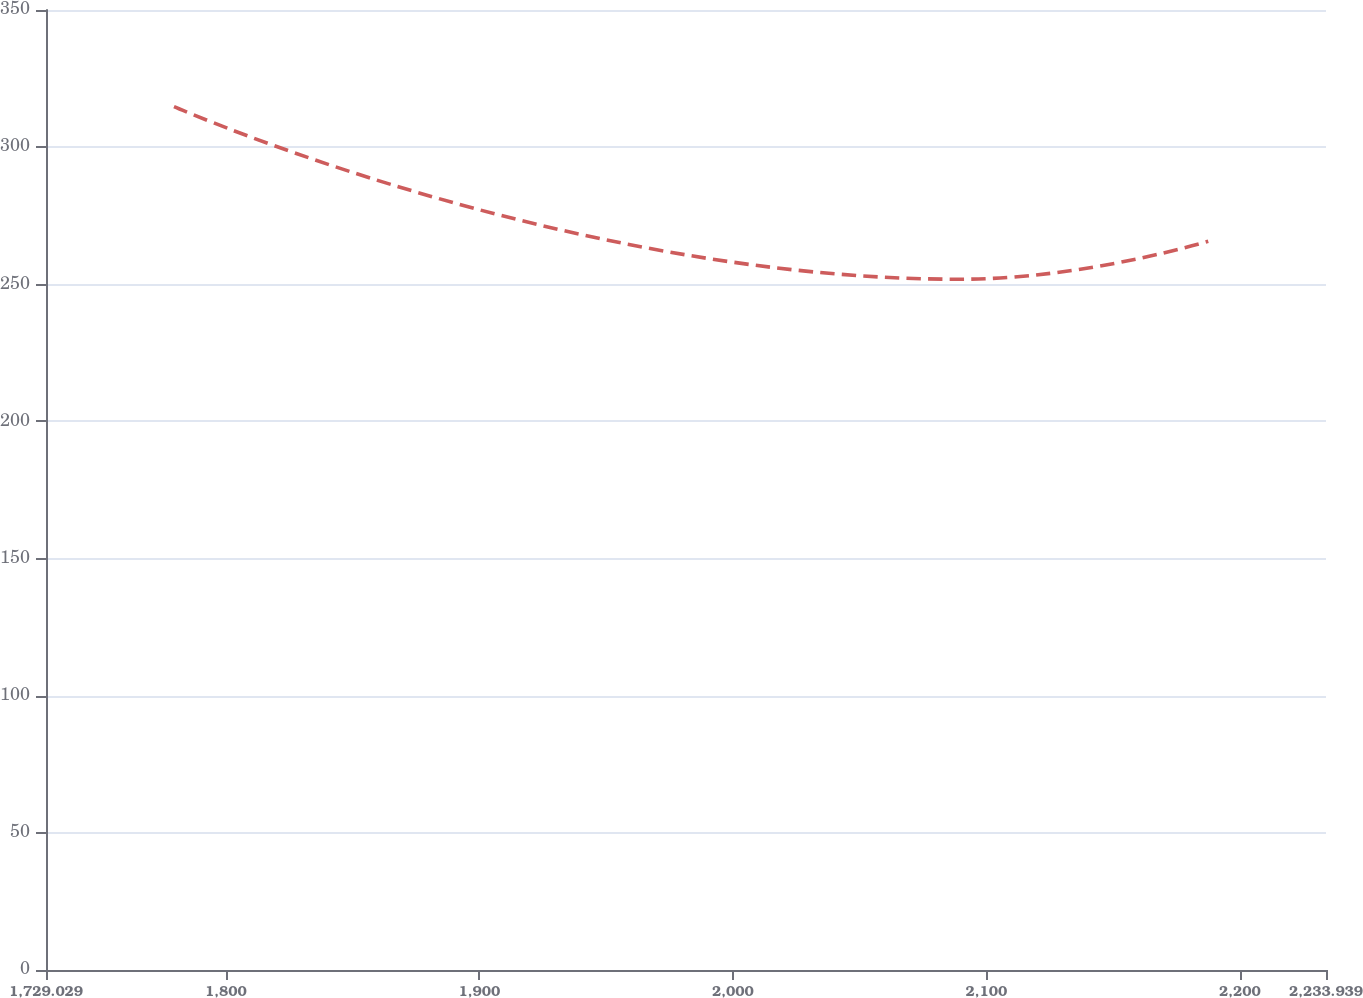<chart> <loc_0><loc_0><loc_500><loc_500><line_chart><ecel><fcel>$ 302<nl><fcel>1779.52<fcel>314.8<nl><fcel>2089.49<fcel>251.83<nl><fcel>2187.49<fcel>265.66<nl><fcel>2284.43<fcel>191.54<nl></chart> 